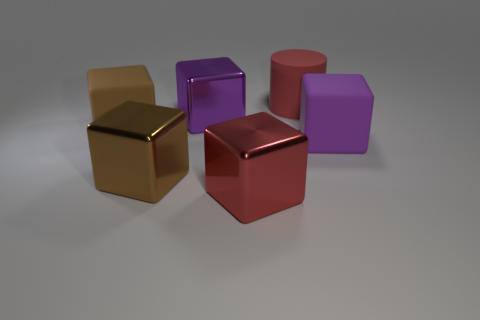Subtract all purple shiny cubes. How many cubes are left? 4 Subtract all green cylinders. How many purple blocks are left? 2 Subtract 1 cubes. How many cubes are left? 4 Subtract all red blocks. How many blocks are left? 4 Add 3 small purple metallic blocks. How many objects exist? 9 Subtract all yellow cubes. Subtract all red cylinders. How many cubes are left? 5 Subtract all large gray objects. Subtract all red cylinders. How many objects are left? 5 Add 2 big red rubber objects. How many big red rubber objects are left? 3 Add 4 large rubber blocks. How many large rubber blocks exist? 6 Subtract 0 gray cylinders. How many objects are left? 6 